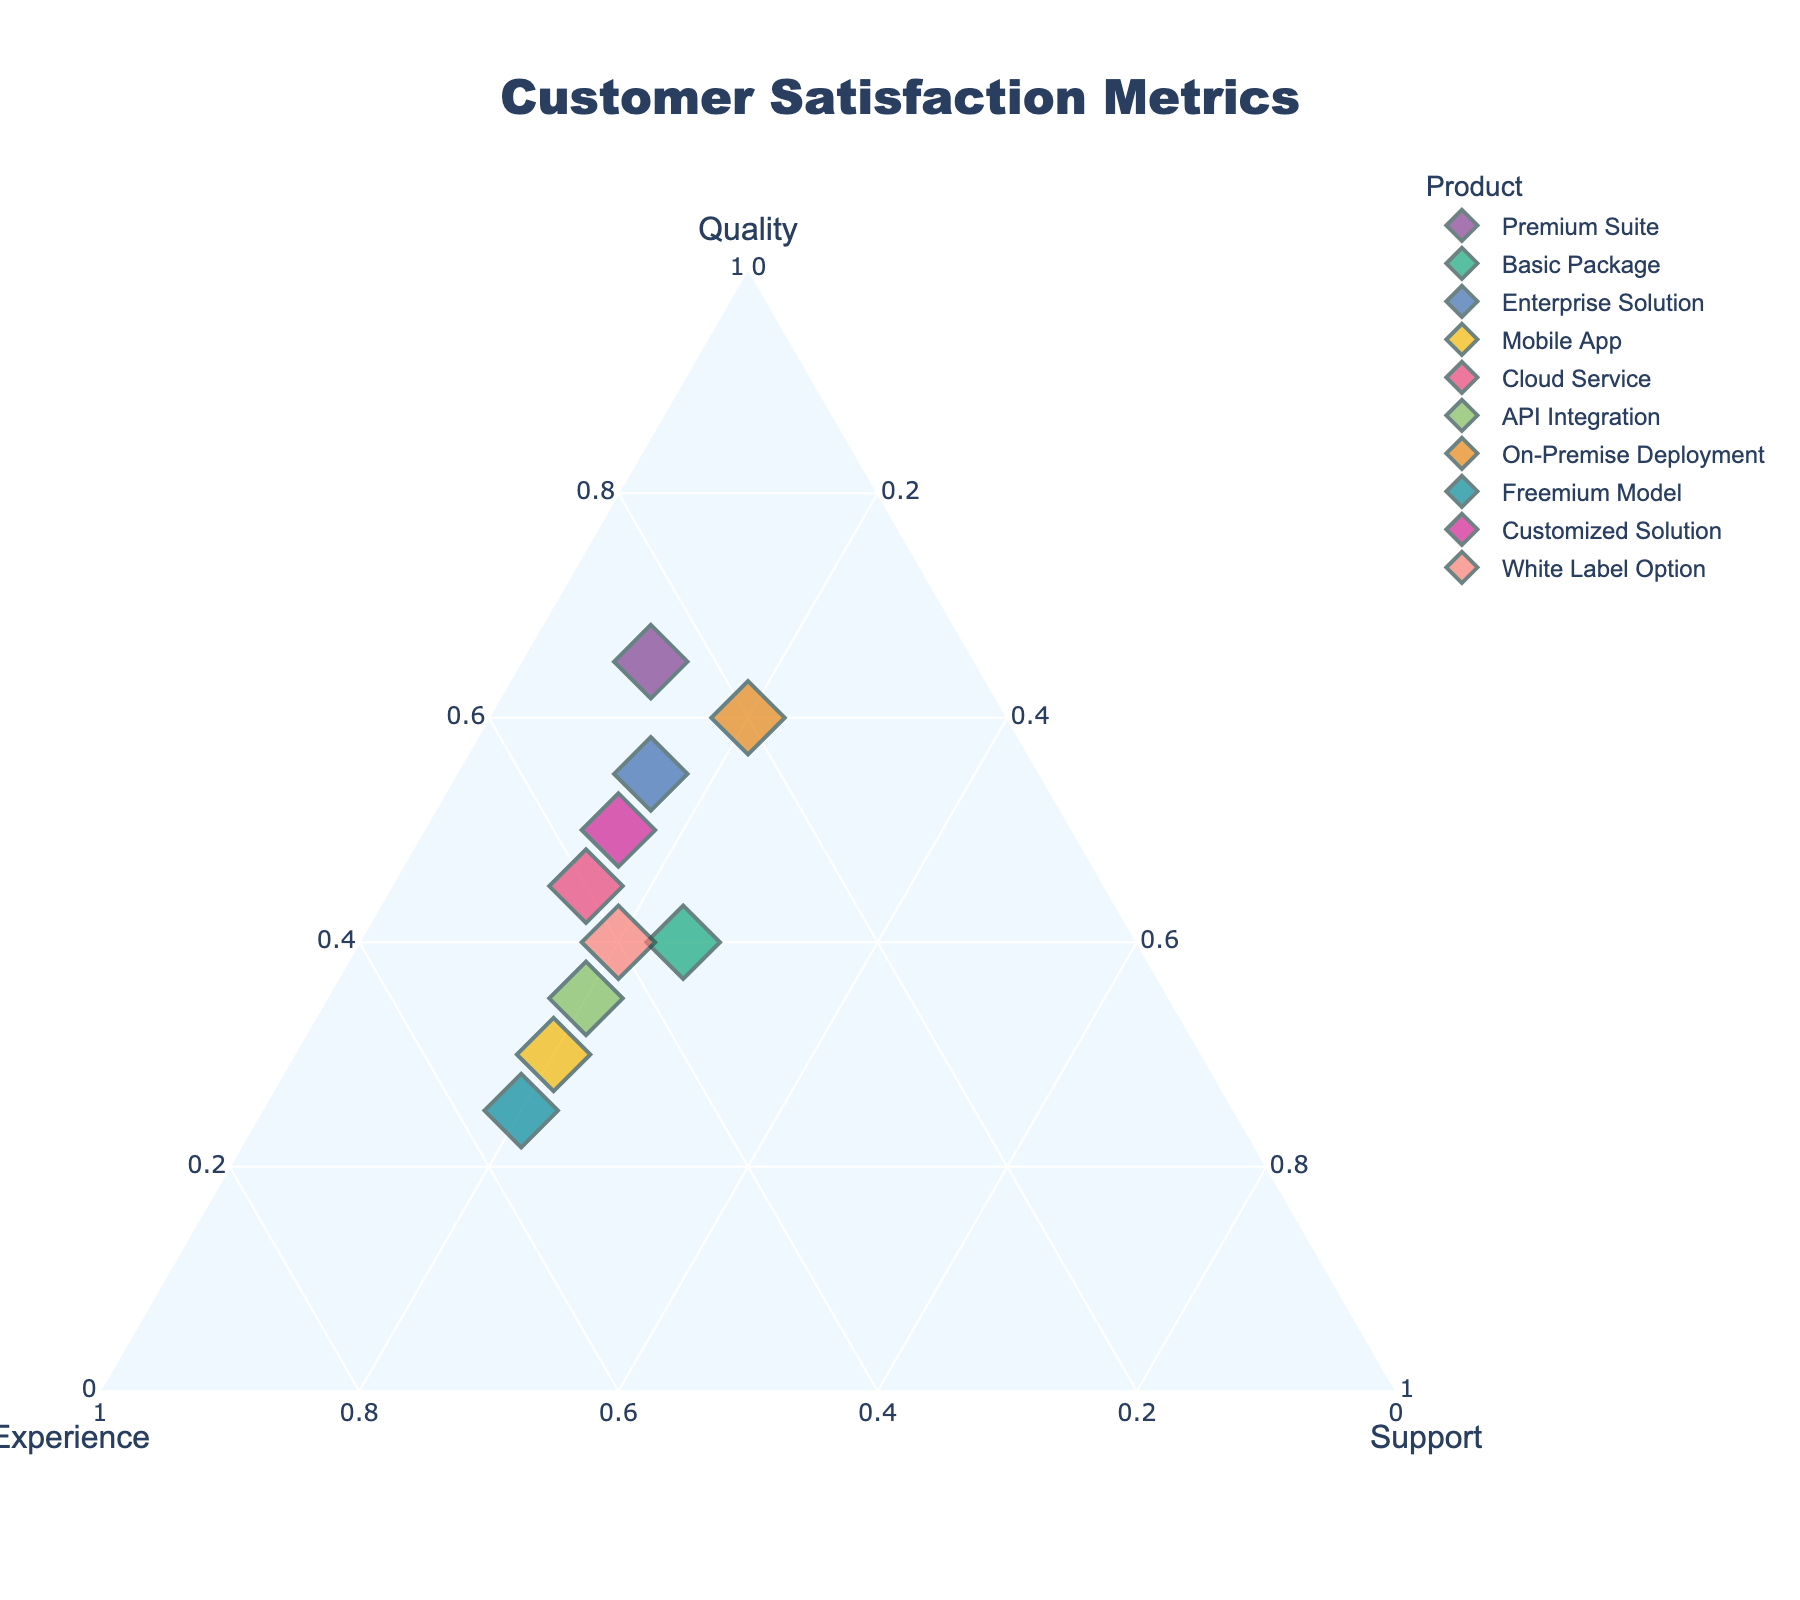What is the title of the plot? The title of the plot is stated at the top of the figure.
Answer: Customer Satisfaction Metrics How many data points are plotted in the figure? The figure plots one data point for each product listed in the data. By counting the products, we find there are 10 data points.
Answer: 10 Which product has the highest Quality metric? By locating each product on the ternary plot along the Quality axis, the Premium Suite has the highest Quality metric value of 0.65.
Answer: Premium Suite What is the combined value of Experience and Support for the Basic Package? To find the combined value of Experience and Support for the Basic Package, add the Experience metric (0.35) and the Support metric (0.25). 0.35 + 0.25 = 0.60
Answer: 0.60 Does any product have an equal value for Experience and Support? By examining the values for Experience and Support across all products, we see that White Label Option has equal values of 0.40 for both Experience and Support.
Answer: White Label Option Which product balances highest between Experience and Support? To determine the balance, we look for a product with high and roughly equal values for Experience and Support. Freemium Model has the highest combined and balanced values (0.55 for Experience and 0.20 for Support).
Answer: Freemium Model Is the sum of Quality and Support greater for the Enterprise Solution or the On-Premise Deployment? For the Enterprise Solution, the sum is 0.55 (Quality) + 0.15 (Support) = 0.70. For the On-Premise Deployment, the sum is 0.60 + 0.20 = 0.80. Hence, On-Premise Deployment has a greater sum.
Answer: On-Premise Deployment Which product emphasizes Support less compared to Experience and Quality? Support values are comparatively low across all products. The Premium Suite has the lowest Support value at 0.10, suggesting it emphasizes it the least compared to Experience (0.25) and Quality (0.65).
Answer: Premium Suite Are there any products where the Quality metric contributes to exactly half of the total satisfaction? For the Quality metric to be exactly half, the Quality value should be 0.50. The Customized Solution has a Quality metric of 0.50, making it contribute to exactly half of the total satisfaction.
Answer: Customized Solution 